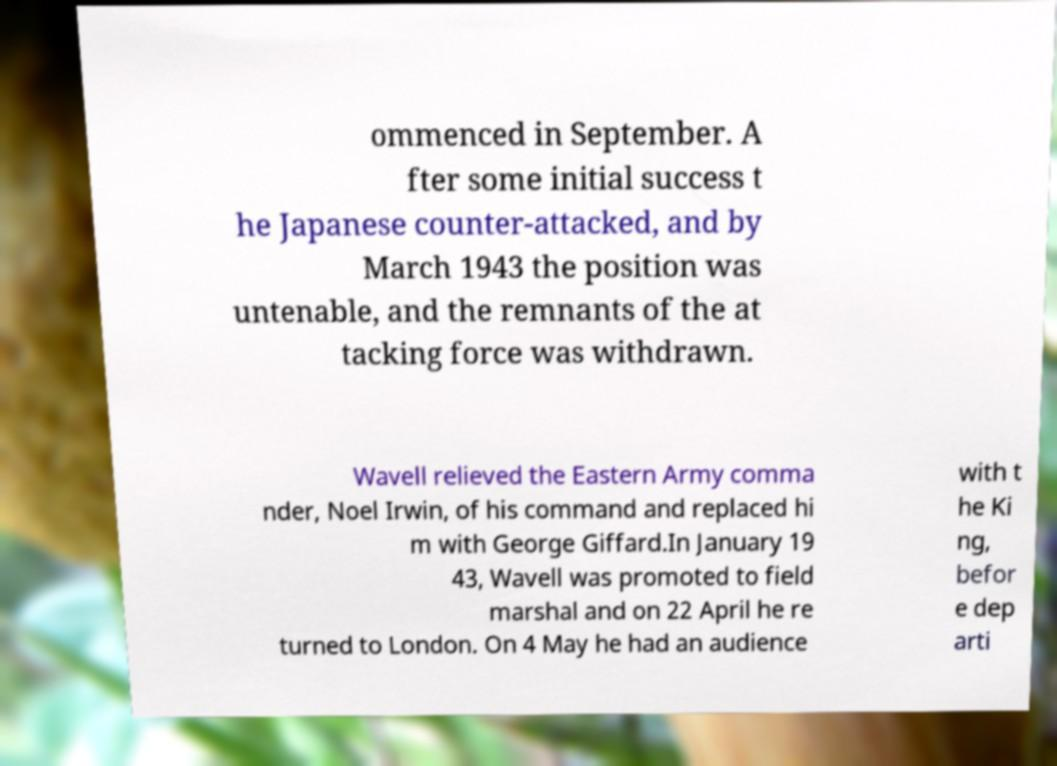Could you extract and type out the text from this image? ommenced in September. A fter some initial success t he Japanese counter-attacked, and by March 1943 the position was untenable, and the remnants of the at tacking force was withdrawn. Wavell relieved the Eastern Army comma nder, Noel Irwin, of his command and replaced hi m with George Giffard.In January 19 43, Wavell was promoted to field marshal and on 22 April he re turned to London. On 4 May he had an audience with t he Ki ng, befor e dep arti 